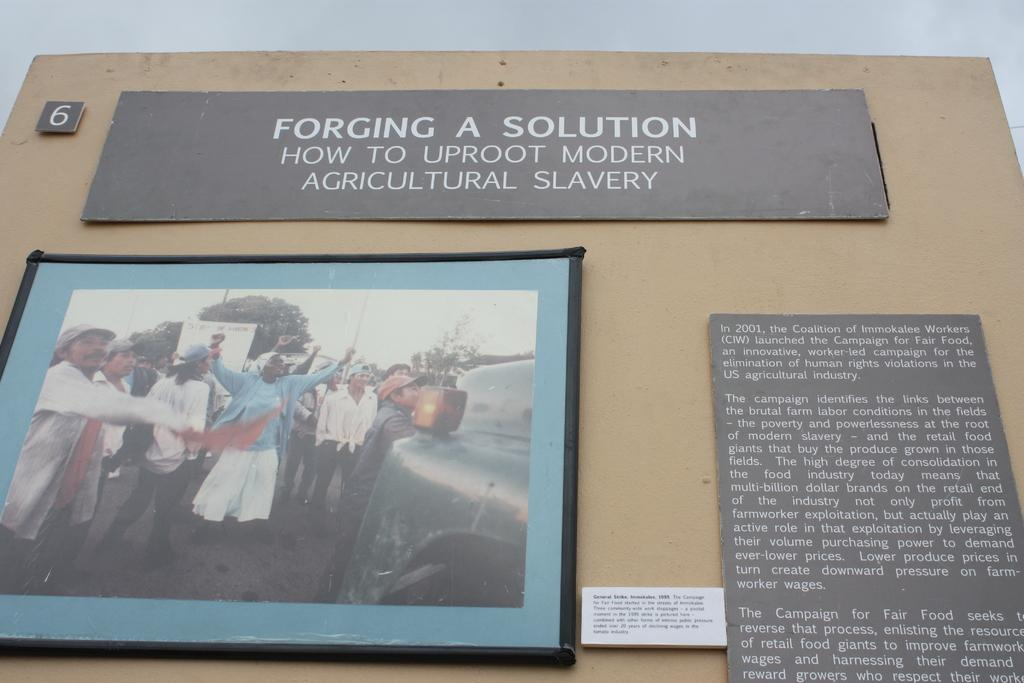Provide a one-sentence caption for the provided image. Exhibit 6 consists of three placards, one of which is a photo, that addresses how to solve the problem of modern agricultural slavery. 